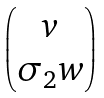<formula> <loc_0><loc_0><loc_500><loc_500>\begin{pmatrix} v \\ \sigma _ { 2 } w \end{pmatrix}</formula> 